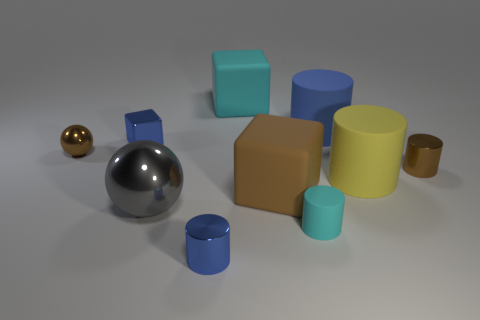Subtract all yellow cylinders. How many cylinders are left? 4 Subtract all cyan rubber cylinders. How many cylinders are left? 4 Subtract 2 cylinders. How many cylinders are left? 3 Subtract all brown cylinders. Subtract all cyan spheres. How many cylinders are left? 4 Subtract all blocks. How many objects are left? 7 Add 2 tiny metal blocks. How many tiny metal blocks are left? 3 Add 10 big red rubber cubes. How many big red rubber cubes exist? 10 Subtract 0 purple blocks. How many objects are left? 10 Subtract all tiny brown matte cylinders. Subtract all brown metallic cylinders. How many objects are left? 9 